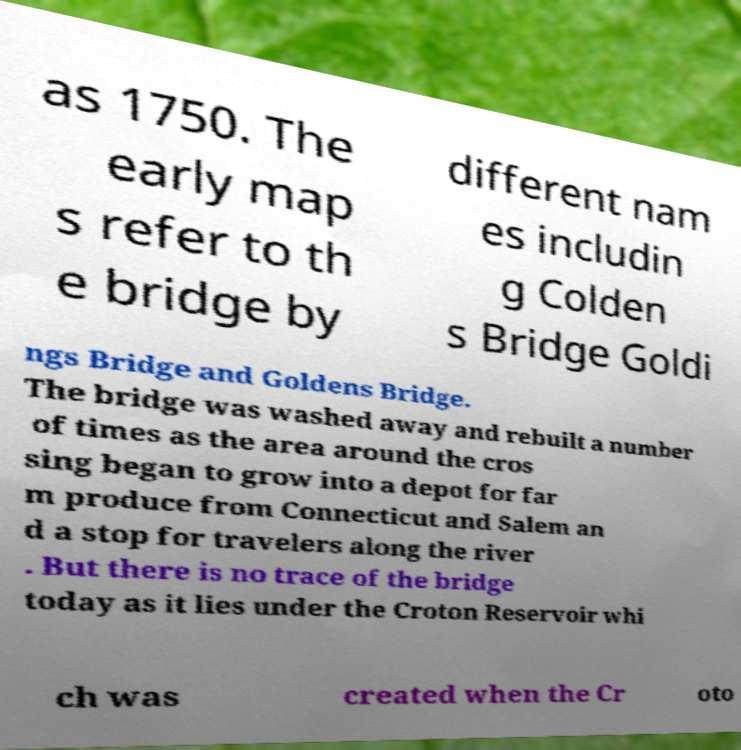Can you read and provide the text displayed in the image?This photo seems to have some interesting text. Can you extract and type it out for me? as 1750. The early map s refer to th e bridge by different nam es includin g Colden s Bridge Goldi ngs Bridge and Goldens Bridge. The bridge was washed away and rebuilt a number of times as the area around the cros sing began to grow into a depot for far m produce from Connecticut and Salem an d a stop for travelers along the river . But there is no trace of the bridge today as it lies under the Croton Reservoir whi ch was created when the Cr oto 